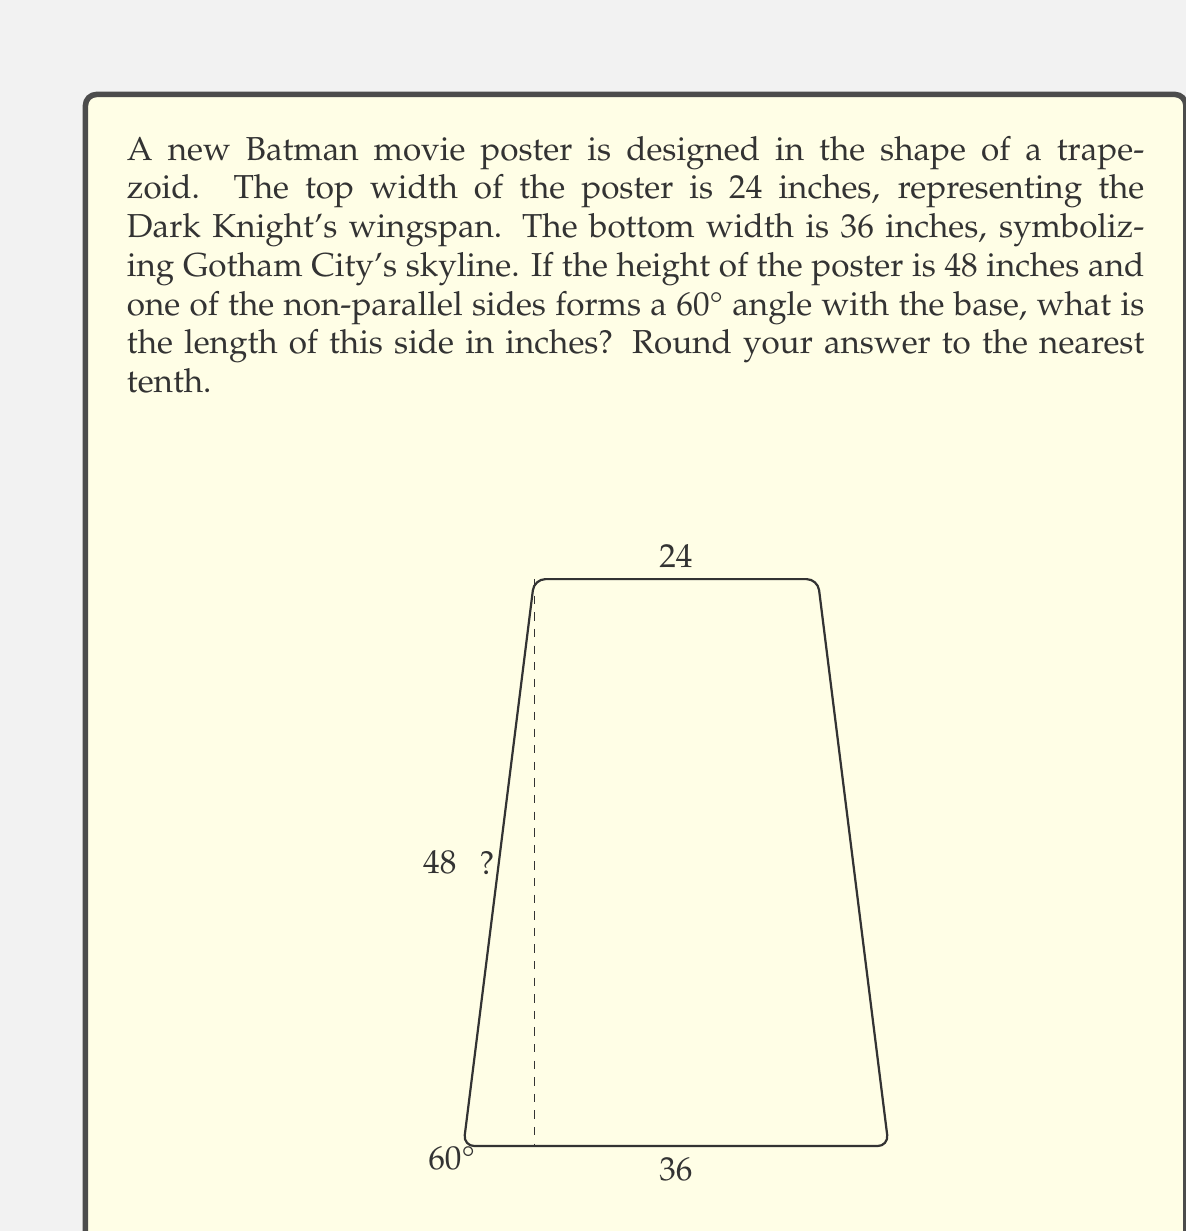Can you answer this question? Let's approach this step-by-step:

1) First, we need to recognize that the trapezoid can be divided into a rectangle and a right triangle.

2) The difference between the bottom and top widths gives us the base of this right triangle:
   $36 - 24 = 12$ inches

3) We know the height of the trapezoid, which is also the height of this right triangle: 48 inches

4) We're given that the angle between the side we're looking for and the base is 60°

5) In this right triangle, we now know:
   - The adjacent side to the 60° angle (12 inches)
   - The opposite side to the 60° angle (48 inches)
   - We're looking for the hypotenuse

6) We can use the tangent function:
   $$\tan 60° = \frac{\text{opposite}}{\text{adjacent}} = \frac{48}{12} = 4$$

7) We know that $\tan 60° = \sqrt{3}$, so this checks out as $\sqrt{3} \approx 1.732$ and $4/\sqrt{3} \approx 2.309$

8) To find the hypotenuse (our side length), we can use the Pythagorean theorem:
   $$\text{side}^2 = 12^2 + 48^2$$

9) Solving this:
   $$\text{side}^2 = 144 + 2304 = 2448$$
   $$\text{side} = \sqrt{2448} \approx 49.4770$$

10) Rounding to the nearest tenth: 49.5 inches
Answer: 49.5 inches 